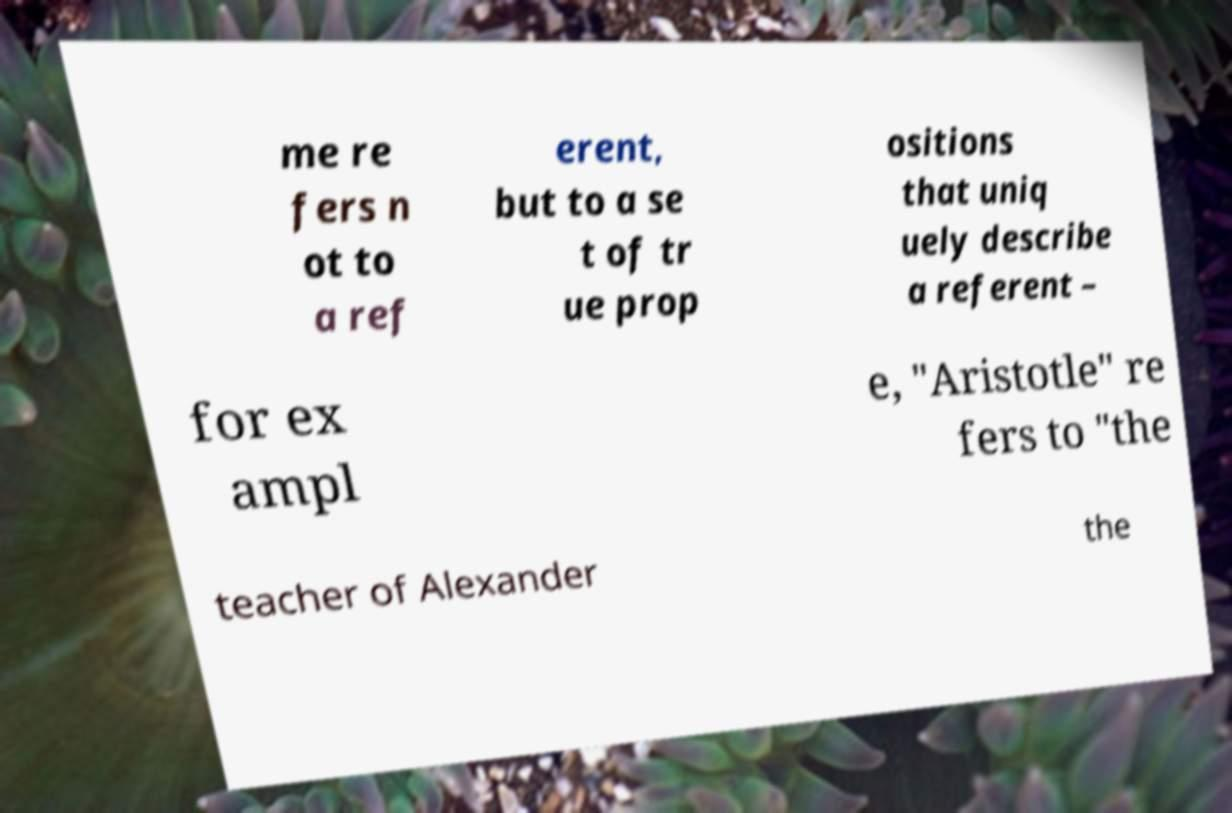Please read and relay the text visible in this image. What does it say? me re fers n ot to a ref erent, but to a se t of tr ue prop ositions that uniq uely describe a referent – for ex ampl e, "Aristotle" re fers to "the teacher of Alexander the 